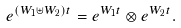<formula> <loc_0><loc_0><loc_500><loc_500>e ^ { ( W _ { 1 } \uplus W _ { 2 } ) t } = e ^ { W _ { 1 } t } \otimes e ^ { W _ { 2 } t } .</formula> 